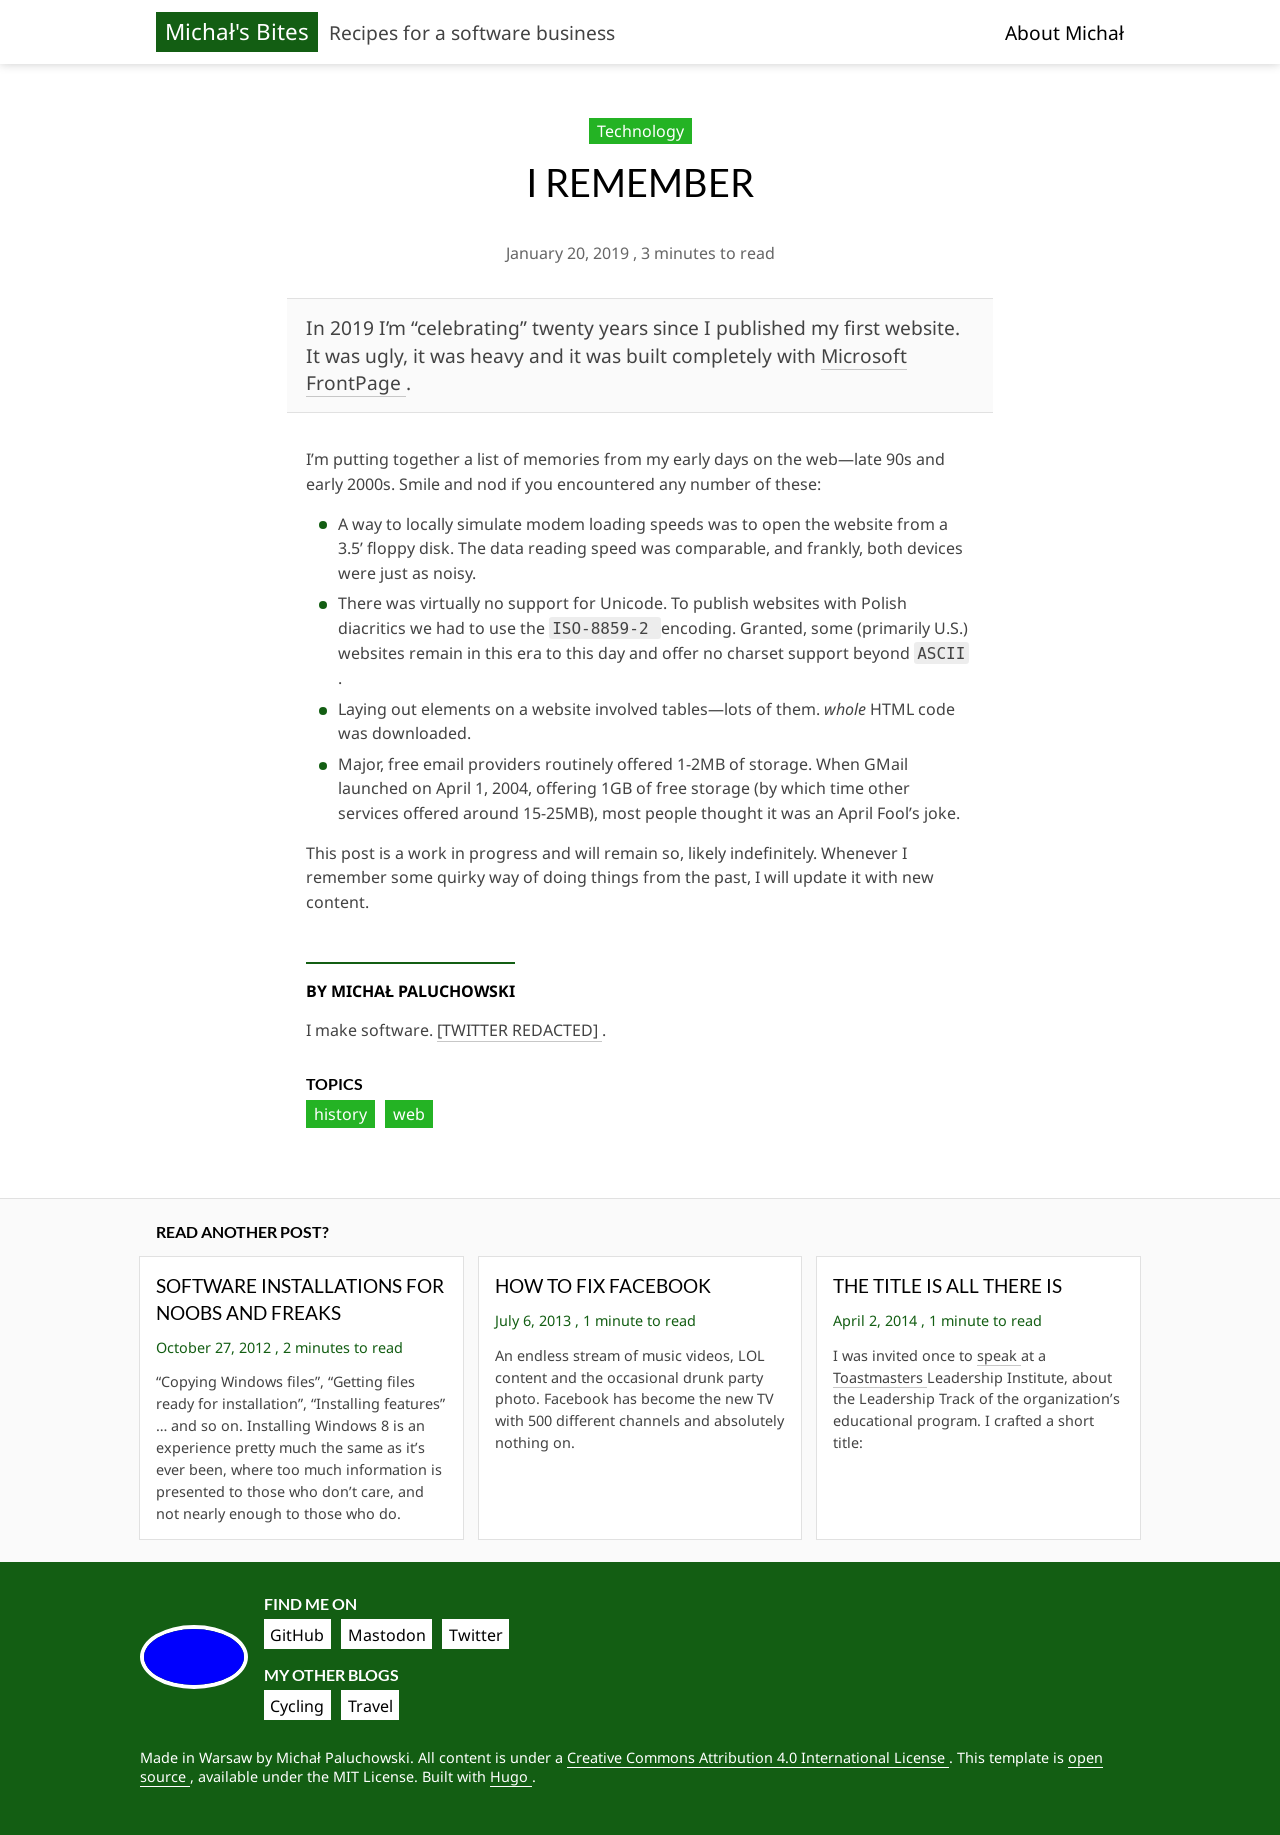How can I start building this website with HTML from the ground up? To start building a website with HTML from scratch, begin by setting up the basic structure: 

<!DOCTYPE html>
<html>
<head>
    <title>Your Website's Title</title>
</head>
<body>
    <h1>Welcome to My Website</h1>
    <p>This is a paragraph of text to start off your website.</p>
</body>
</html>

This code sets up a basic HTML page with a title, heading, and a paragraph. From here, you can expand by adding more HTML elements such as links, images, lists, and additional pages. Remember to save your file with a .html extension and you can view it in any web browser. 